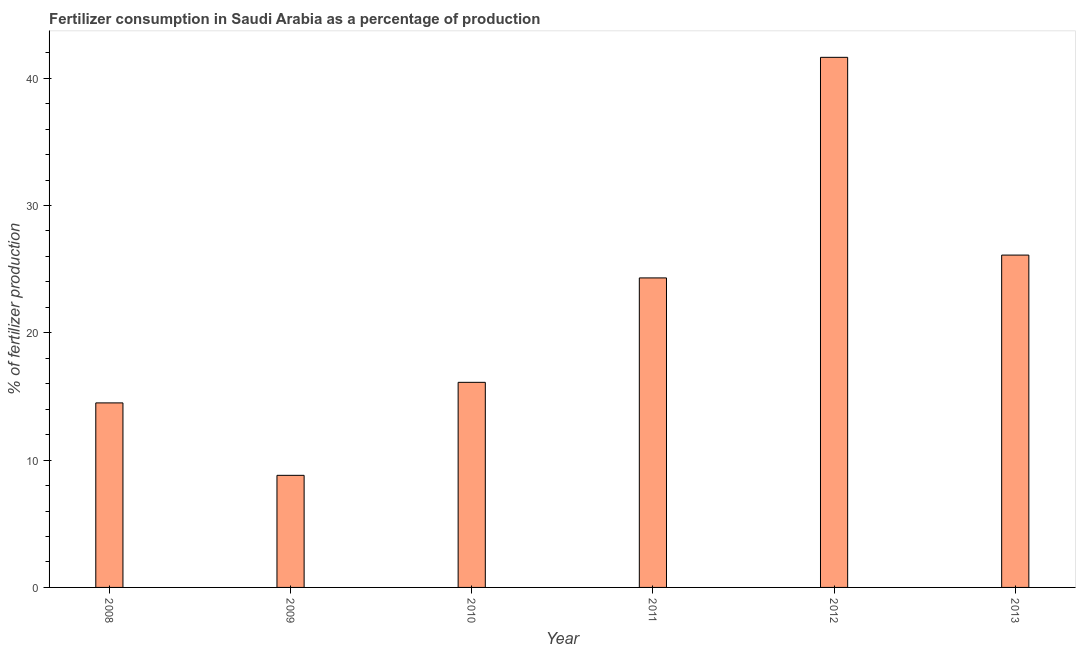What is the title of the graph?
Ensure brevity in your answer.  Fertilizer consumption in Saudi Arabia as a percentage of production. What is the label or title of the X-axis?
Ensure brevity in your answer.  Year. What is the label or title of the Y-axis?
Offer a terse response. % of fertilizer production. What is the amount of fertilizer consumption in 2010?
Your response must be concise. 16.11. Across all years, what is the maximum amount of fertilizer consumption?
Keep it short and to the point. 41.64. Across all years, what is the minimum amount of fertilizer consumption?
Your answer should be very brief. 8.81. In which year was the amount of fertilizer consumption minimum?
Ensure brevity in your answer.  2009. What is the sum of the amount of fertilizer consumption?
Your answer should be compact. 131.47. What is the difference between the amount of fertilizer consumption in 2010 and 2012?
Your answer should be very brief. -25.53. What is the average amount of fertilizer consumption per year?
Your answer should be very brief. 21.91. What is the median amount of fertilizer consumption?
Your answer should be compact. 20.21. In how many years, is the amount of fertilizer consumption greater than 6 %?
Your answer should be compact. 6. What is the ratio of the amount of fertilizer consumption in 2009 to that in 2012?
Ensure brevity in your answer.  0.21. What is the difference between the highest and the second highest amount of fertilizer consumption?
Offer a very short reply. 15.53. Is the sum of the amount of fertilizer consumption in 2012 and 2013 greater than the maximum amount of fertilizer consumption across all years?
Your response must be concise. Yes. What is the difference between the highest and the lowest amount of fertilizer consumption?
Keep it short and to the point. 32.83. In how many years, is the amount of fertilizer consumption greater than the average amount of fertilizer consumption taken over all years?
Offer a very short reply. 3. Are all the bars in the graph horizontal?
Keep it short and to the point. No. How many years are there in the graph?
Your response must be concise. 6. What is the difference between two consecutive major ticks on the Y-axis?
Your response must be concise. 10. What is the % of fertilizer production in 2008?
Provide a succinct answer. 14.49. What is the % of fertilizer production of 2009?
Keep it short and to the point. 8.81. What is the % of fertilizer production in 2010?
Your answer should be very brief. 16.11. What is the % of fertilizer production of 2011?
Keep it short and to the point. 24.31. What is the % of fertilizer production of 2012?
Your answer should be very brief. 41.64. What is the % of fertilizer production in 2013?
Provide a short and direct response. 26.11. What is the difference between the % of fertilizer production in 2008 and 2009?
Your response must be concise. 5.69. What is the difference between the % of fertilizer production in 2008 and 2010?
Give a very brief answer. -1.62. What is the difference between the % of fertilizer production in 2008 and 2011?
Provide a succinct answer. -9.82. What is the difference between the % of fertilizer production in 2008 and 2012?
Offer a terse response. -27.15. What is the difference between the % of fertilizer production in 2008 and 2013?
Offer a terse response. -11.61. What is the difference between the % of fertilizer production in 2009 and 2010?
Your answer should be compact. -7.3. What is the difference between the % of fertilizer production in 2009 and 2011?
Provide a short and direct response. -15.51. What is the difference between the % of fertilizer production in 2009 and 2012?
Offer a terse response. -32.83. What is the difference between the % of fertilizer production in 2009 and 2013?
Provide a short and direct response. -17.3. What is the difference between the % of fertilizer production in 2010 and 2011?
Your answer should be very brief. -8.2. What is the difference between the % of fertilizer production in 2010 and 2012?
Give a very brief answer. -25.53. What is the difference between the % of fertilizer production in 2010 and 2013?
Make the answer very short. -10. What is the difference between the % of fertilizer production in 2011 and 2012?
Your answer should be very brief. -17.33. What is the difference between the % of fertilizer production in 2011 and 2013?
Your response must be concise. -1.79. What is the difference between the % of fertilizer production in 2012 and 2013?
Provide a succinct answer. 15.53. What is the ratio of the % of fertilizer production in 2008 to that in 2009?
Make the answer very short. 1.65. What is the ratio of the % of fertilizer production in 2008 to that in 2010?
Provide a succinct answer. 0.9. What is the ratio of the % of fertilizer production in 2008 to that in 2011?
Your answer should be compact. 0.6. What is the ratio of the % of fertilizer production in 2008 to that in 2012?
Offer a terse response. 0.35. What is the ratio of the % of fertilizer production in 2008 to that in 2013?
Your response must be concise. 0.56. What is the ratio of the % of fertilizer production in 2009 to that in 2010?
Offer a very short reply. 0.55. What is the ratio of the % of fertilizer production in 2009 to that in 2011?
Ensure brevity in your answer.  0.36. What is the ratio of the % of fertilizer production in 2009 to that in 2012?
Your response must be concise. 0.21. What is the ratio of the % of fertilizer production in 2009 to that in 2013?
Make the answer very short. 0.34. What is the ratio of the % of fertilizer production in 2010 to that in 2011?
Offer a terse response. 0.66. What is the ratio of the % of fertilizer production in 2010 to that in 2012?
Offer a terse response. 0.39. What is the ratio of the % of fertilizer production in 2010 to that in 2013?
Your answer should be compact. 0.62. What is the ratio of the % of fertilizer production in 2011 to that in 2012?
Your answer should be very brief. 0.58. What is the ratio of the % of fertilizer production in 2011 to that in 2013?
Offer a very short reply. 0.93. What is the ratio of the % of fertilizer production in 2012 to that in 2013?
Provide a succinct answer. 1.59. 